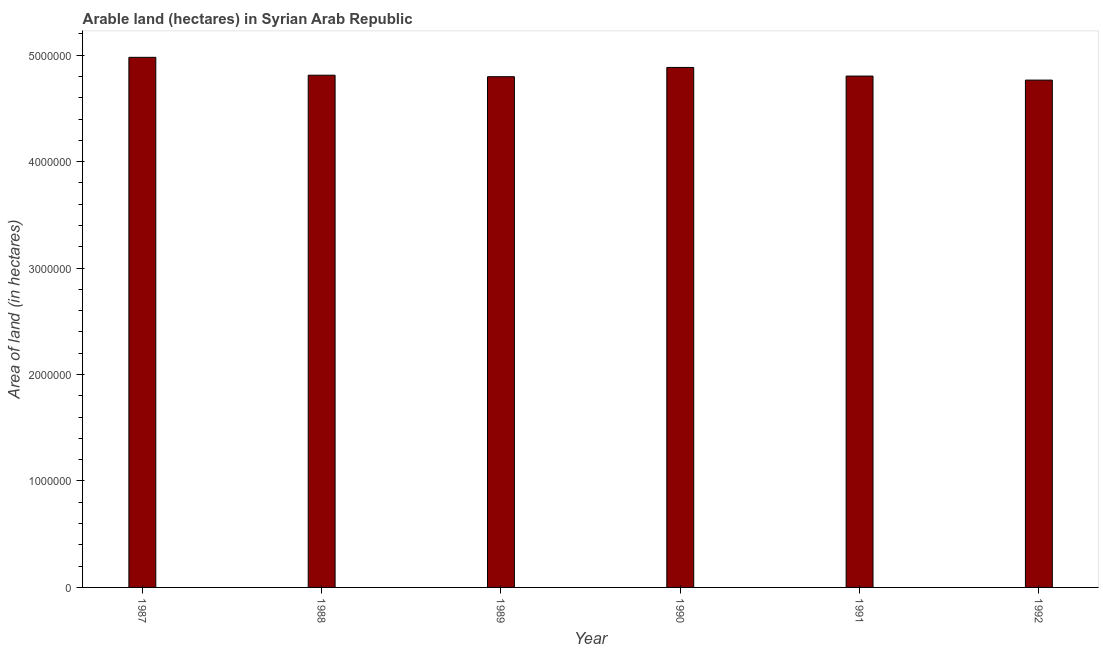Does the graph contain grids?
Give a very brief answer. No. What is the title of the graph?
Give a very brief answer. Arable land (hectares) in Syrian Arab Republic. What is the label or title of the X-axis?
Offer a terse response. Year. What is the label or title of the Y-axis?
Keep it short and to the point. Area of land (in hectares). What is the area of land in 1987?
Offer a terse response. 4.98e+06. Across all years, what is the maximum area of land?
Your answer should be compact. 4.98e+06. Across all years, what is the minimum area of land?
Offer a terse response. 4.77e+06. In which year was the area of land maximum?
Provide a short and direct response. 1987. In which year was the area of land minimum?
Give a very brief answer. 1992. What is the sum of the area of land?
Provide a short and direct response. 2.90e+07. What is the difference between the area of land in 1989 and 1990?
Ensure brevity in your answer.  -8.70e+04. What is the average area of land per year?
Your answer should be very brief. 4.84e+06. What is the median area of land?
Offer a very short reply. 4.81e+06. What is the ratio of the area of land in 1989 to that in 1992?
Keep it short and to the point. 1.01. Is the area of land in 1989 less than that in 1991?
Ensure brevity in your answer.  Yes. Is the difference between the area of land in 1987 and 1991 greater than the difference between any two years?
Your response must be concise. No. What is the difference between the highest and the second highest area of land?
Provide a short and direct response. 9.50e+04. Is the sum of the area of land in 1987 and 1989 greater than the maximum area of land across all years?
Your answer should be compact. Yes. What is the difference between the highest and the lowest area of land?
Keep it short and to the point. 2.14e+05. In how many years, is the area of land greater than the average area of land taken over all years?
Provide a short and direct response. 2. How many bars are there?
Keep it short and to the point. 6. How many years are there in the graph?
Provide a succinct answer. 6. What is the difference between two consecutive major ticks on the Y-axis?
Give a very brief answer. 1.00e+06. What is the Area of land (in hectares) in 1987?
Your response must be concise. 4.98e+06. What is the Area of land (in hectares) in 1988?
Offer a very short reply. 4.81e+06. What is the Area of land (in hectares) of 1989?
Your answer should be compact. 4.80e+06. What is the Area of land (in hectares) in 1990?
Provide a succinct answer. 4.88e+06. What is the Area of land (in hectares) in 1991?
Make the answer very short. 4.80e+06. What is the Area of land (in hectares) in 1992?
Offer a terse response. 4.77e+06. What is the difference between the Area of land (in hectares) in 1987 and 1988?
Offer a terse response. 1.68e+05. What is the difference between the Area of land (in hectares) in 1987 and 1989?
Offer a very short reply. 1.82e+05. What is the difference between the Area of land (in hectares) in 1987 and 1990?
Make the answer very short. 9.50e+04. What is the difference between the Area of land (in hectares) in 1987 and 1991?
Give a very brief answer. 1.76e+05. What is the difference between the Area of land (in hectares) in 1987 and 1992?
Give a very brief answer. 2.14e+05. What is the difference between the Area of land (in hectares) in 1988 and 1989?
Make the answer very short. 1.40e+04. What is the difference between the Area of land (in hectares) in 1988 and 1990?
Offer a very short reply. -7.30e+04. What is the difference between the Area of land (in hectares) in 1988 and 1991?
Ensure brevity in your answer.  8000. What is the difference between the Area of land (in hectares) in 1988 and 1992?
Make the answer very short. 4.60e+04. What is the difference between the Area of land (in hectares) in 1989 and 1990?
Provide a succinct answer. -8.70e+04. What is the difference between the Area of land (in hectares) in 1989 and 1991?
Your answer should be compact. -6000. What is the difference between the Area of land (in hectares) in 1989 and 1992?
Provide a short and direct response. 3.20e+04. What is the difference between the Area of land (in hectares) in 1990 and 1991?
Your answer should be compact. 8.10e+04. What is the difference between the Area of land (in hectares) in 1990 and 1992?
Your answer should be compact. 1.19e+05. What is the difference between the Area of land (in hectares) in 1991 and 1992?
Keep it short and to the point. 3.80e+04. What is the ratio of the Area of land (in hectares) in 1987 to that in 1988?
Keep it short and to the point. 1.03. What is the ratio of the Area of land (in hectares) in 1987 to that in 1989?
Make the answer very short. 1.04. What is the ratio of the Area of land (in hectares) in 1987 to that in 1991?
Make the answer very short. 1.04. What is the ratio of the Area of land (in hectares) in 1987 to that in 1992?
Your answer should be compact. 1.04. What is the ratio of the Area of land (in hectares) in 1988 to that in 1990?
Offer a very short reply. 0.98. What is the ratio of the Area of land (in hectares) in 1988 to that in 1991?
Offer a very short reply. 1. What is the ratio of the Area of land (in hectares) in 1988 to that in 1992?
Offer a very short reply. 1.01. What is the ratio of the Area of land (in hectares) in 1989 to that in 1990?
Ensure brevity in your answer.  0.98. What is the ratio of the Area of land (in hectares) in 1990 to that in 1992?
Your response must be concise. 1.02. What is the ratio of the Area of land (in hectares) in 1991 to that in 1992?
Your response must be concise. 1.01. 